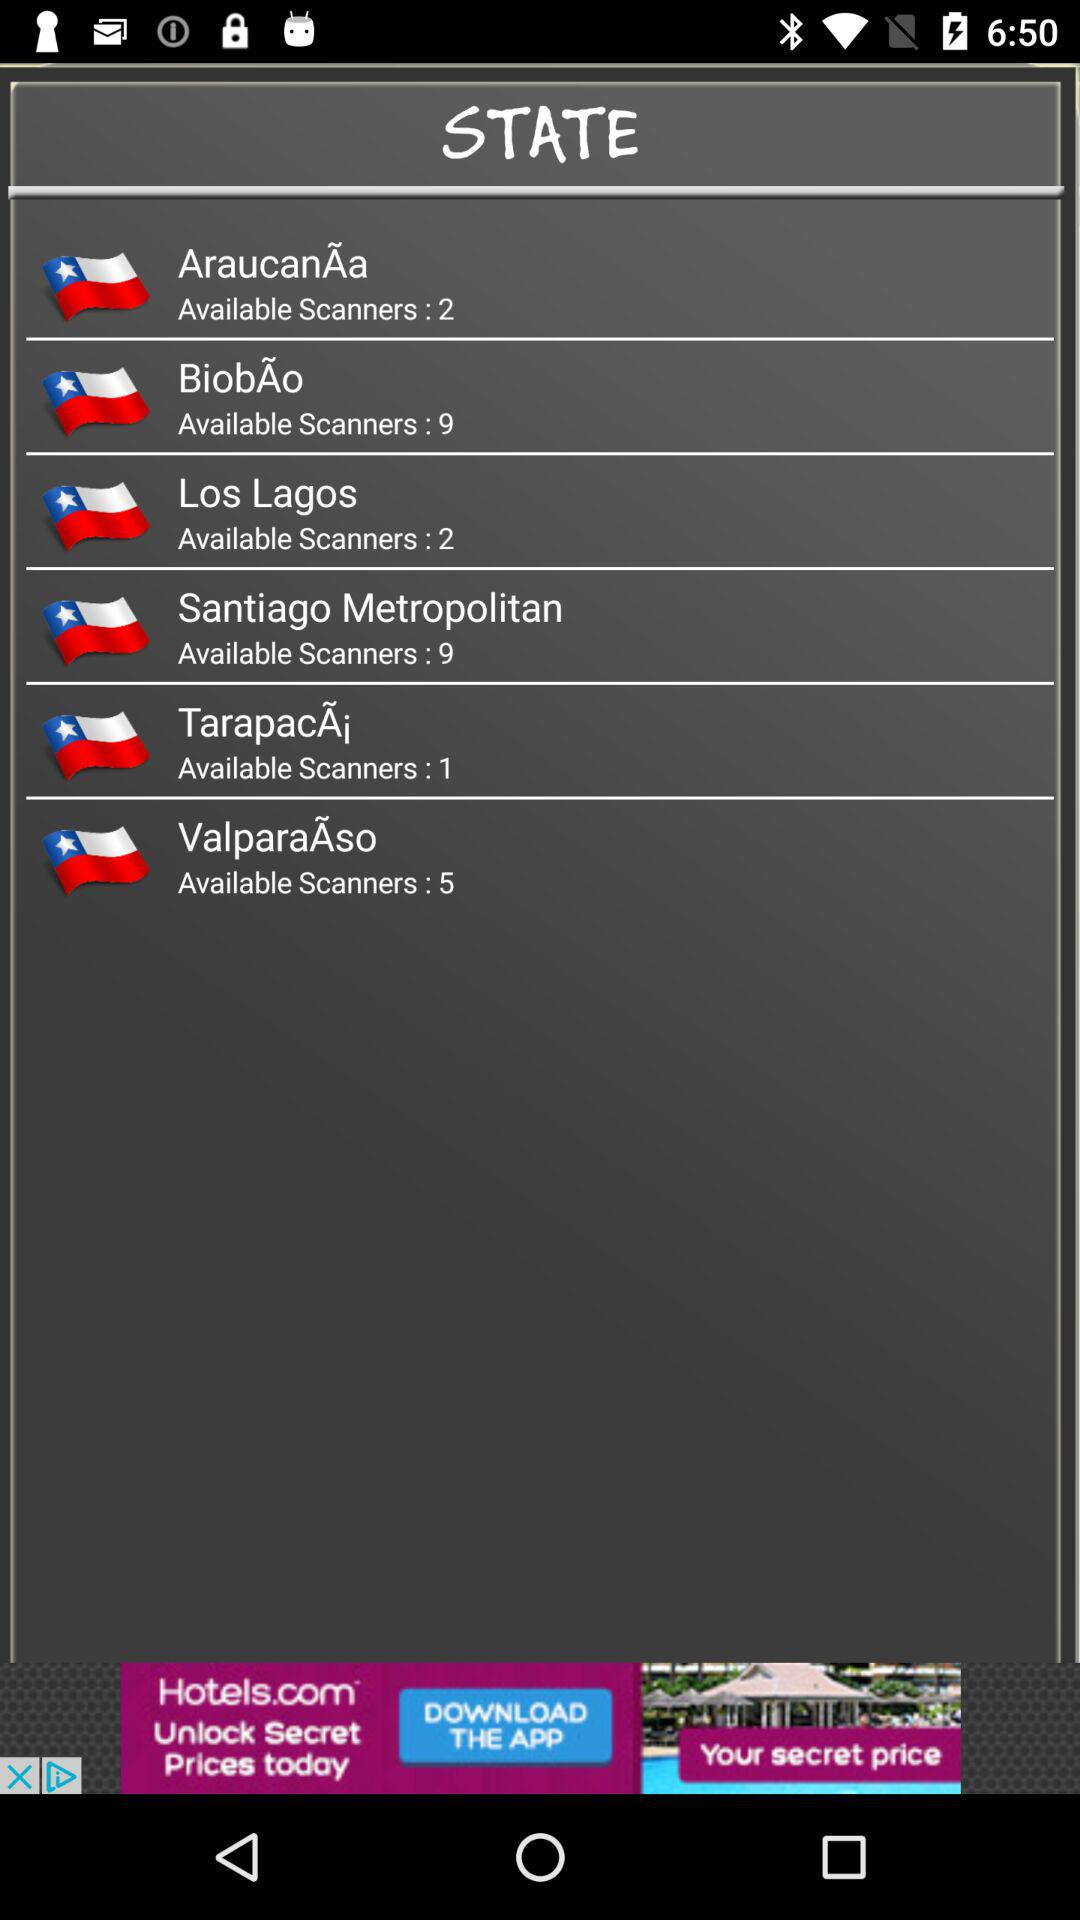How many regions have more than 2 available scanners?
Answer the question using a single word or phrase. 3 